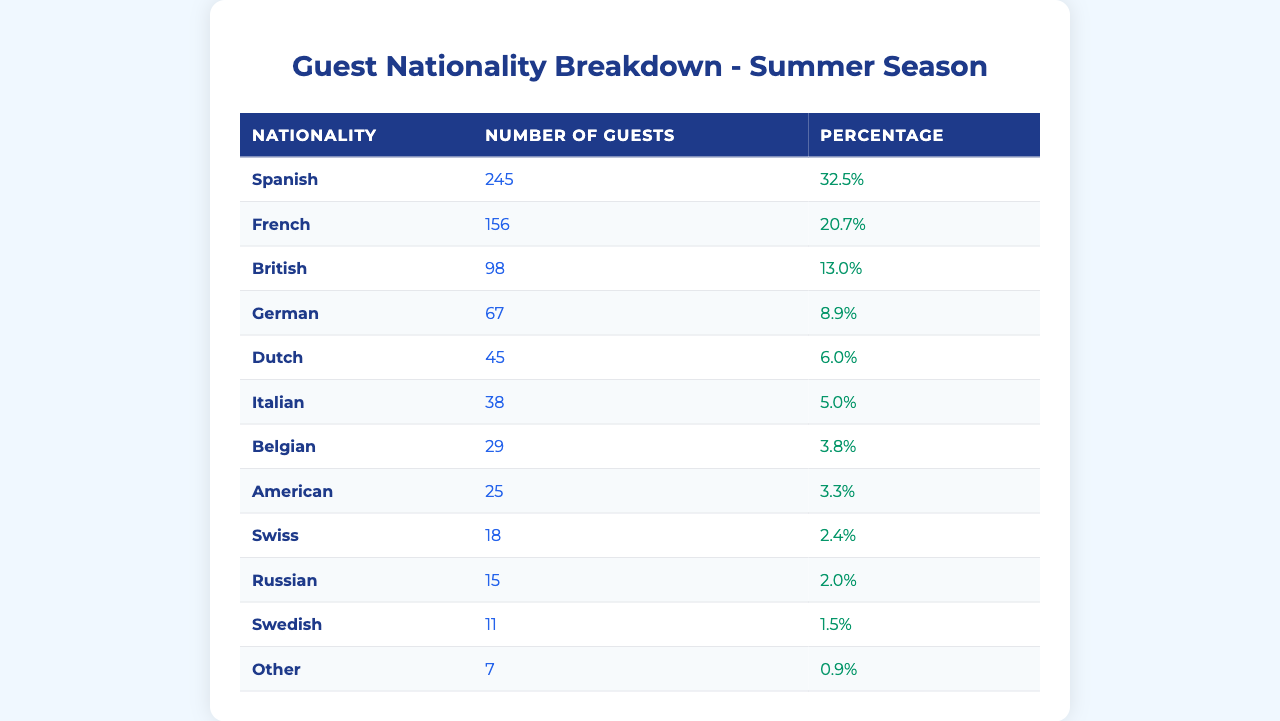What nationality has the highest number of guests? The nationality with the highest number of guests is Spanish, with 245 guests. This can be determined by looking at the "Number of Guests" column and identifying the highest value.
Answer: Spanish What percentage of guests were from the UK? The percentage of guests from the UK is 13.0%. This information is found in the "Percentage" column corresponding to the "British" nationality row.
Answer: 13.0% How many guests were from countries other than Spain, France, and the UK? To find the number of guests from countries other than Spain, France, and the UK, we can sum the number of guests from each of those other nationalities: German (67) + Dutch (45) + Italian (38) + Belgian (29) + American (25) + Swiss (18) + Russian (15) + Swedish (11) + Other (7) =  245 guests. This total excludes the Spanish (245), French (156), and British (98) guests.
Answer: 245 Is the total number of American guests greater than the total number of Belgian guests? The total number of American guests is 25, while the total number of Belgian guests is 29. Since 25 is less than 29, the statement is false.
Answer: No What is the total number of guests from all nationalities combined? To determine the total number of guests, we can sum up all the values in the "Number of Guests" column: 245 + 156 + 98 + 67 + 45 + 38 + 29 + 25 + 18 + 15 + 11 + 7 =  722 guests. This total represents the entire guest population.
Answer: 722 What nationality contributes more than 20% of the total guests? To find out which nationalities contribute more than 20% of total guests, we compare the percentage of each nationality listed. In this case, only Spanish contributes 32.5%, while French contributes 20.7%, which is not more than 20%. Thus, the answer is Spanish only.
Answer: Spanish How many guests were from Italy and Russia combined? The number of guests from Italy is 38 and from Russia is 15. To find the combined total, we add these two numbers: 38 + 15 = 53 guests.
Answer: 53 Which nationality had the least number of guests? The nationality with the least number of guests is "Other," with only 7 guests. This can be identified as the lowest value in the "Number of Guests" column.
Answer: Other If the number of Dutch guests increases by 10, what will be the new total? The current number of Dutch guests is 45. If this increases by 10, the new total will be 45 + 10 = 55. Then, we will need to add this change to the overall guest total of 722: 722 + 10 = 732.
Answer: 732 What is the average number of guests from the top three nationalities? The top three nationalities by number of guests are Spanish (245), French (156), and British (98). To find the average, we sum these numbers: 245 + 156 + 98 = 499 guests, and then divide by 3 (the number of nationalities), which gives us 499 / 3 = 166.33 guests on average.
Answer: 166.33 